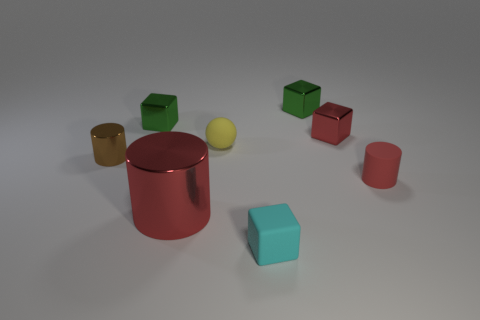Subtract all cyan balls. How many red cylinders are left? 2 Add 1 small brown cylinders. How many objects exist? 9 Subtract all metallic cylinders. How many cylinders are left? 1 Subtract all red blocks. How many blocks are left? 3 Subtract 3 blocks. How many blocks are left? 1 Subtract all balls. How many objects are left? 7 Subtract all cyan cylinders. Subtract all purple balls. How many cylinders are left? 3 Subtract all large yellow metal cylinders. Subtract all blocks. How many objects are left? 4 Add 8 green blocks. How many green blocks are left? 10 Add 7 tiny yellow balls. How many tiny yellow balls exist? 8 